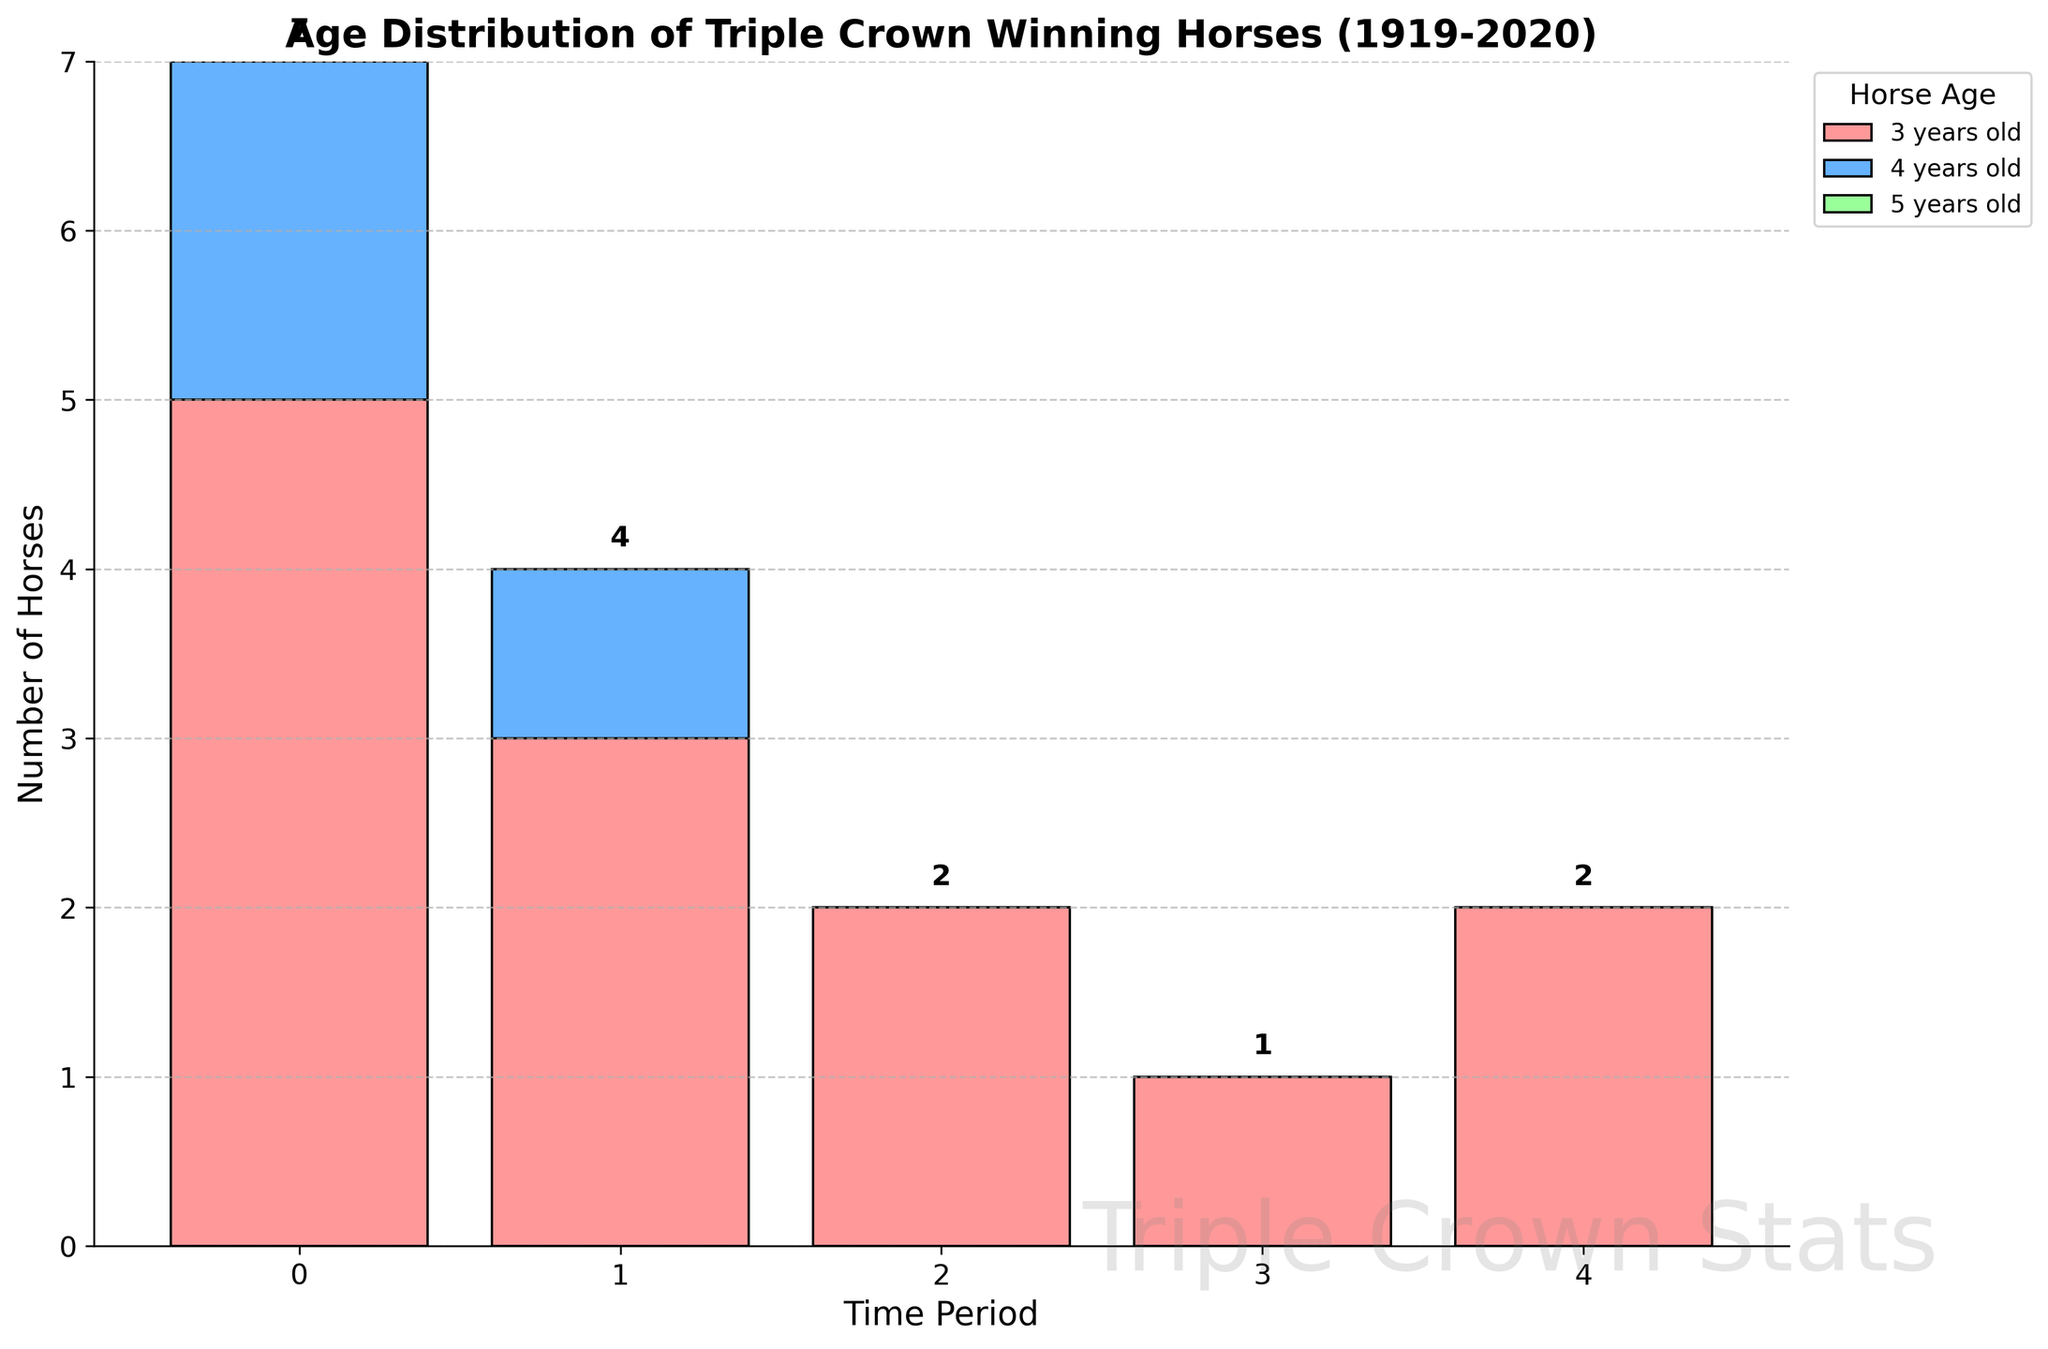what's the title of the figure? The title of the figure is written at the top of the chart. It states the purpose or the content of the visualization.
Answer: Age Distribution of Triple Crown Winning Horses (1919-2020) What are the age groups shown in the chart? The age groups are indicated by different colors in the bar chart's legend.
Answer: 3 years old, 4 years old, 5 years old How many 5-year-old Triple Crown winners were there between 1919 and 2020? According to the height of the green bars labeled for 5-year-olds, and reading off respective values, there were no 5-year-old winners.
Answer: 0 What is the total number of Triple Crown winners in the 1919-1940 period? Sum up the values for all age groups in this period: 5 (age 3) + 2 (age 4) + 0 (age 5).
Answer: 7 Which period had the least number of Triple Crown winners? Comparing all periods visually on the bar chart, the period 1981-2000 had the fewest winners.
Answer: 1981-2000 How do the number of 3-year-old winners compare between 1961-1980 and 2001-2020? Examine the bar heights and values for both periods: 2 (1961–1980) vs 2 (2001–2020), so they are equal.
Answer: Equal What is the total number of 4-year-old Triple Crown winners from 1919 to 2020? Summing up all periods’ values for 4-year-olds: 2 (1919-1940) + 1 (1941-1960) + 0 (1961-1980) + 0 (1981-2000) + 0 (2001-2020).
Answer: 3 Between which periods did the number of 3-year-old winners decrease the most? Compare consecutive periods by subtracting values: 
1941-1960: 3 
1961-1980: 2 
1981-2000: 1 
2001-2020: 2 
The biggest difference is between 1941-1960 and 1961-1980, with a decrease of 1.
Answer: 1941-1960 to 1961-1980 What is the pattern of 4-year-old winners over the periods? Review the bar chart and note how the values change across periods: 
2 (1919-1940) to 1 (1941-1960), then 0 thereafter.
Answer: Decreased, then constant at 0 How does the number of Triple Crown winners in the 1941-1960 period for 4-year-olds compare to 3-year-olds? Check the specific bars for this period: 1 (4-year-olds) vs 3 (3-year-olds). The number of 3-year-olds is greater.
Answer: 3-year-olds have more 